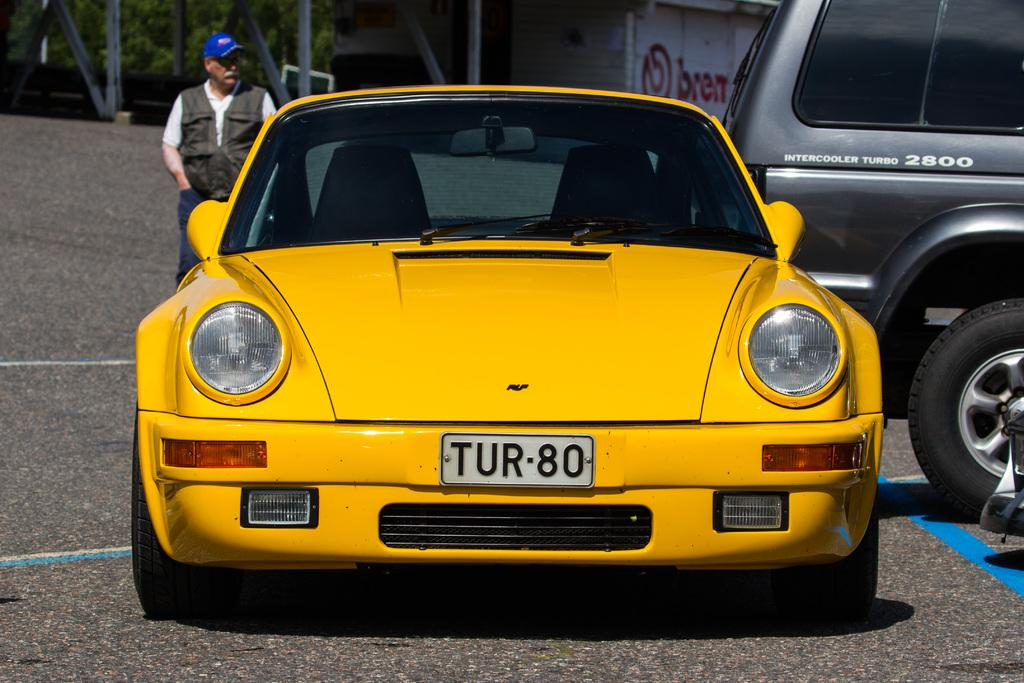What color is the car in the image? The car in the image is yellow. What else can be seen in the background of the image? There is a vehicle, a person, a wall, trees, and other objects in the background of the image. What is at the bottom of the image? There is a road at the bottom of the image. What type of cabbage is growing on the wall in the image? There is no cabbage present in the image; it features a yellow car, a background with various objects, and a road at the bottom. How many spiders can be seen crawling on the person in the background of the image? There are no spiders present in the image; it features a yellow car, a background with various objects, and a road at the bottom. 